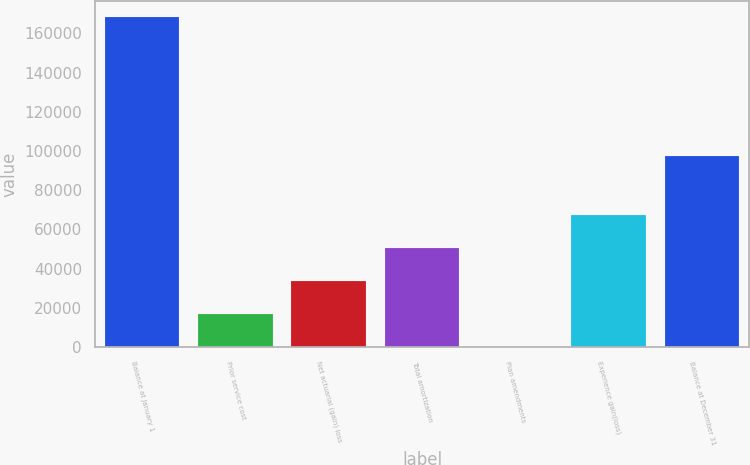<chart> <loc_0><loc_0><loc_500><loc_500><bar_chart><fcel>Balance at January 1<fcel>Prior service cost<fcel>Net actuarial (gain) loss<fcel>Total amortization<fcel>Plan amendments<fcel>Experience gain(loss)<fcel>Balance at December 31<nl><fcel>168129<fcel>16816.6<fcel>33629.1<fcel>50441.6<fcel>4.14<fcel>67254.1<fcel>97467<nl></chart> 